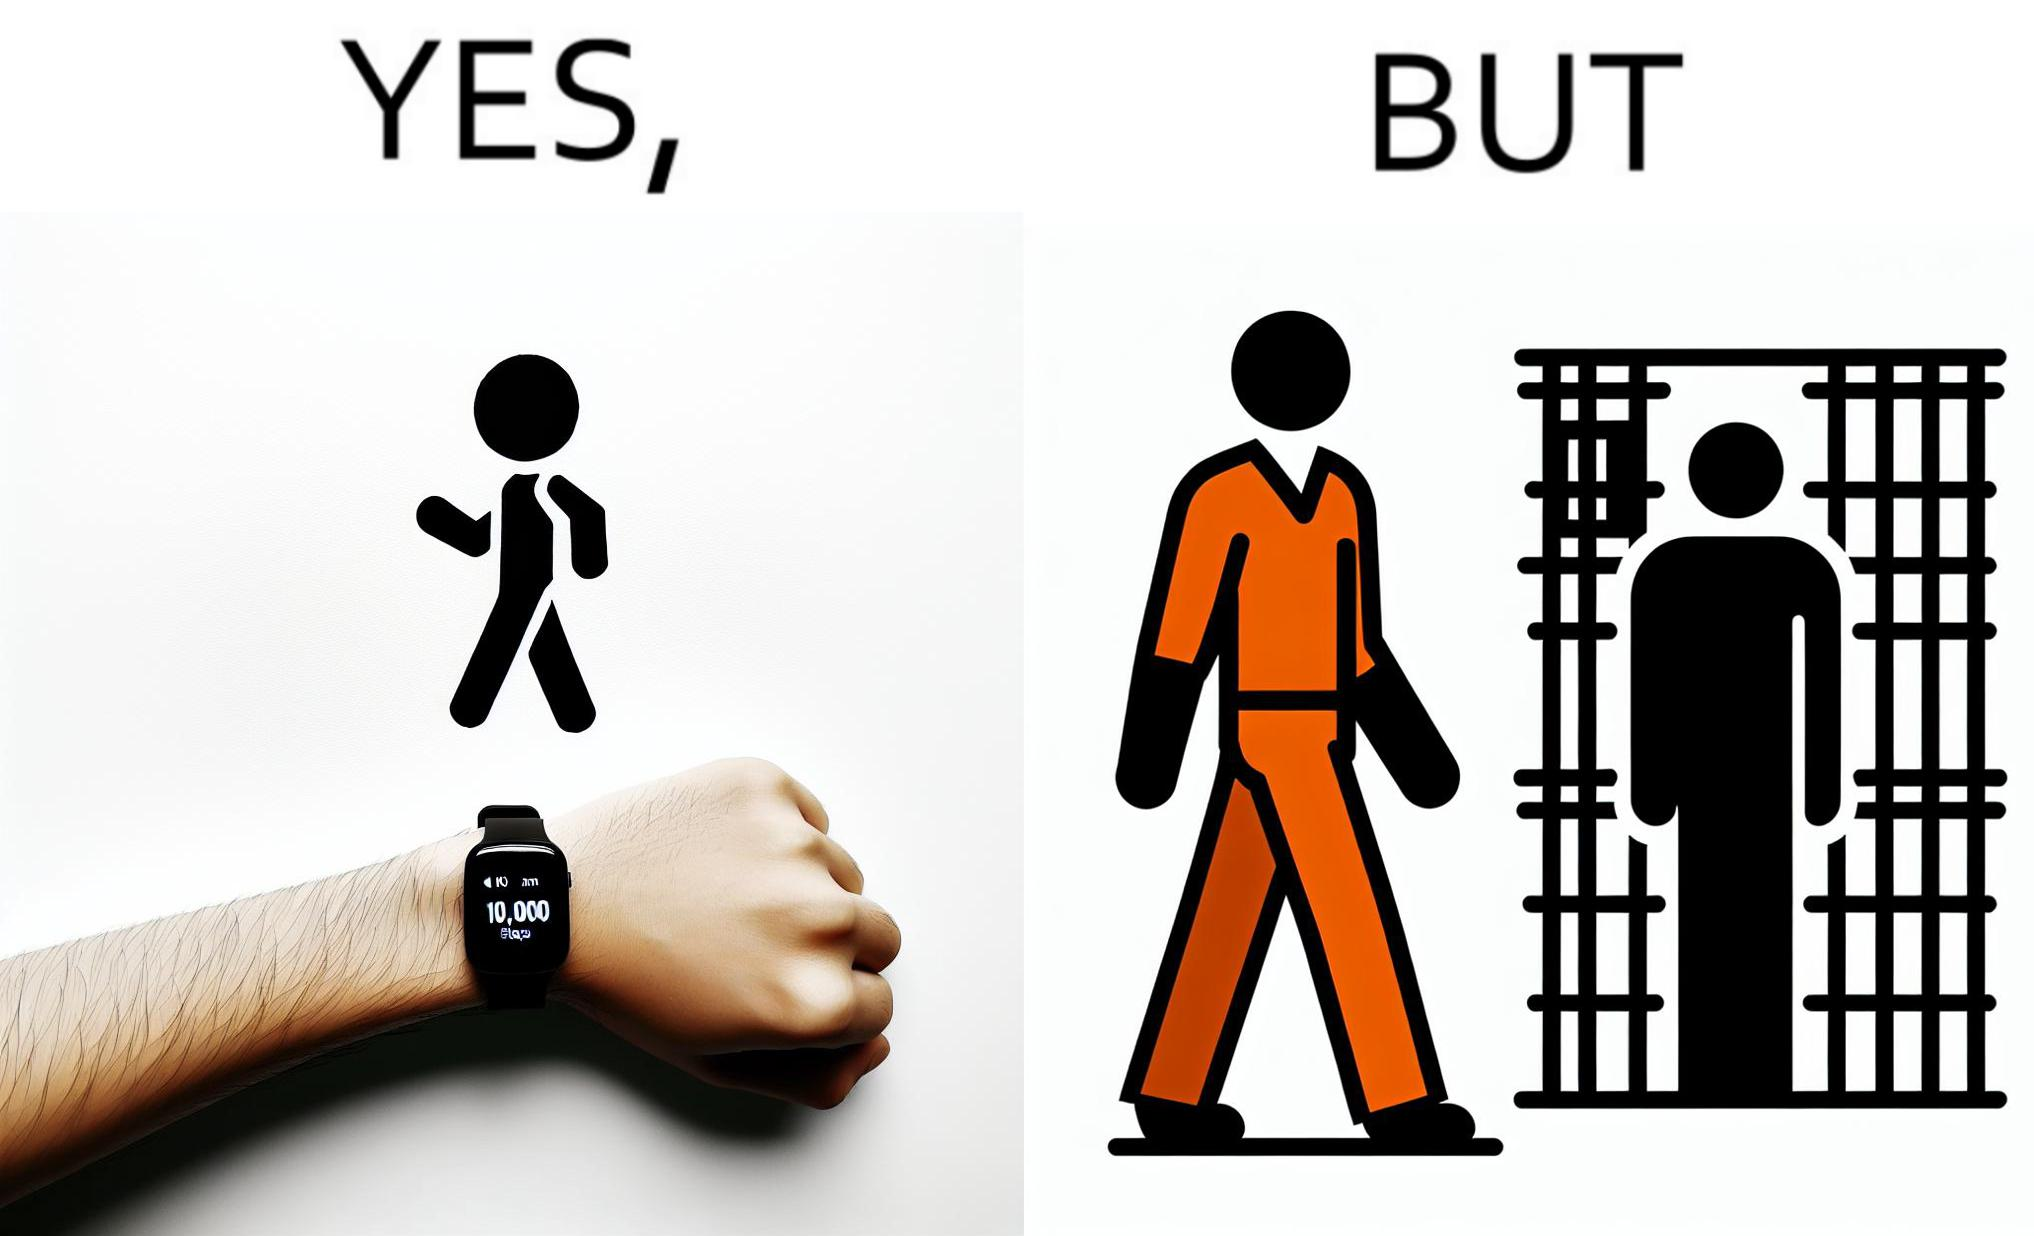What do you see in each half of this image? In the left part of the image: a smartwatch on a person's wrist showing 10,000 steps completed, indicating that a goal has been reached. In the right part of the image: a person walking in orange clothes, who is apparently a prisoner inside a jail. 